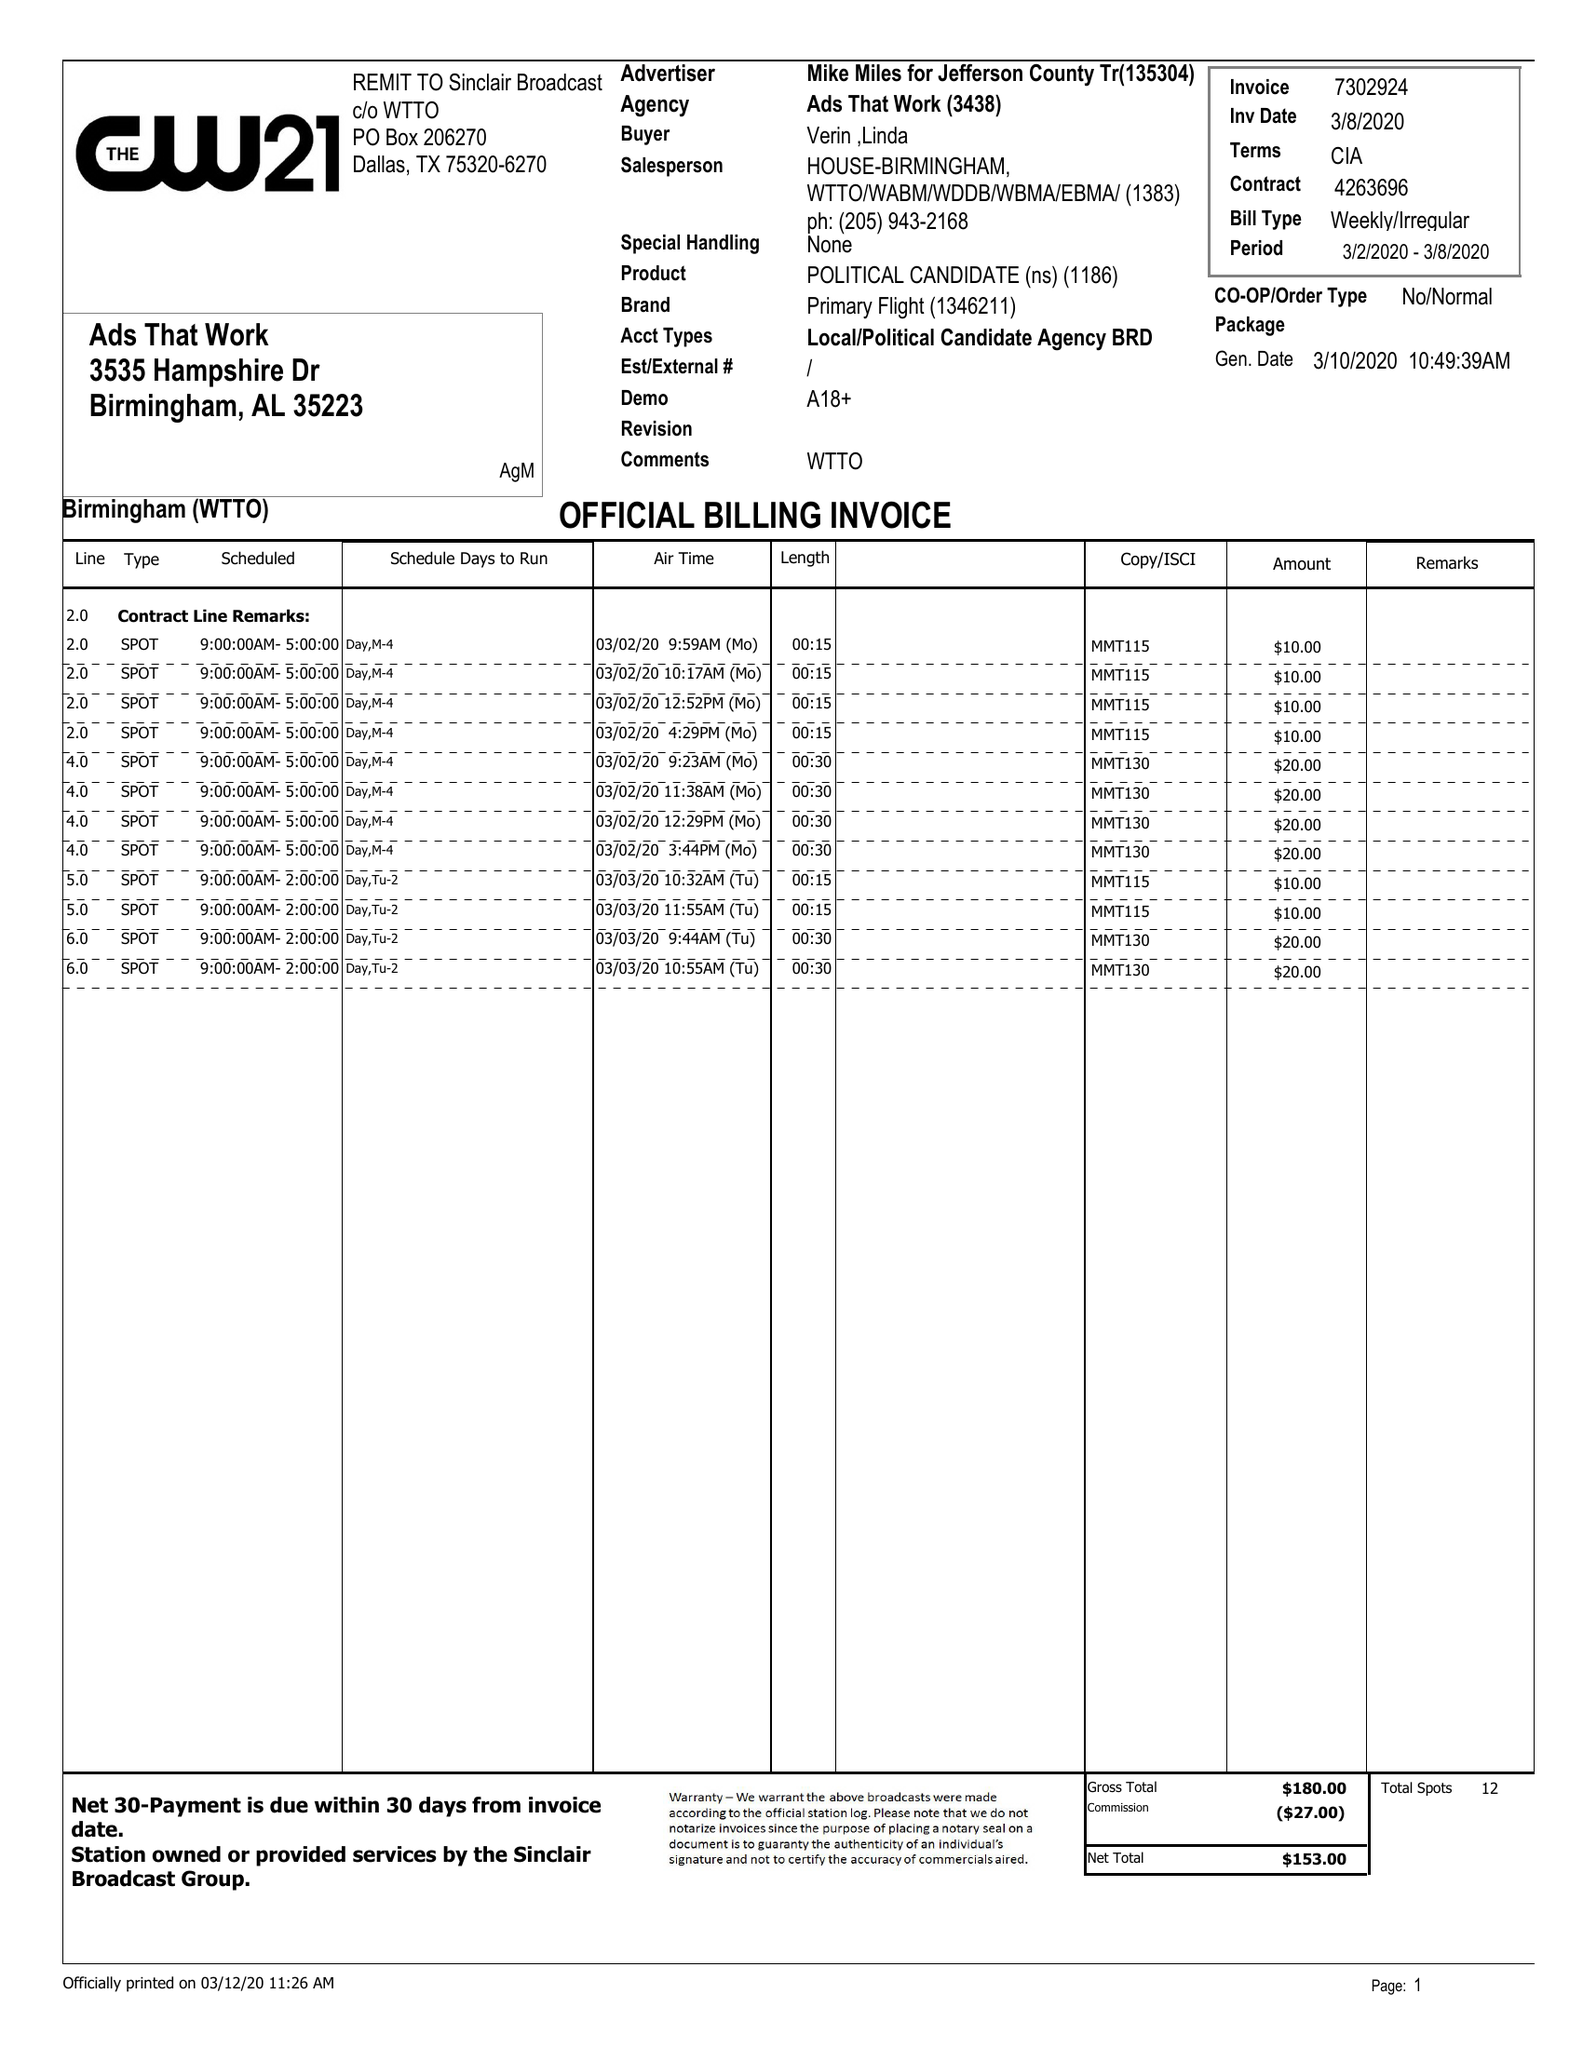What is the value for the flight_to?
Answer the question using a single word or phrase. 03/08/20 